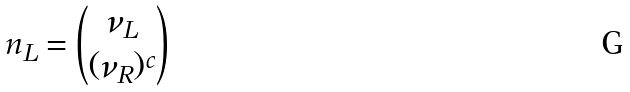Convert formula to latex. <formula><loc_0><loc_0><loc_500><loc_500>n _ { L } = { \nu _ { L } \choose ( \nu _ { R } ) ^ { c } }</formula> 